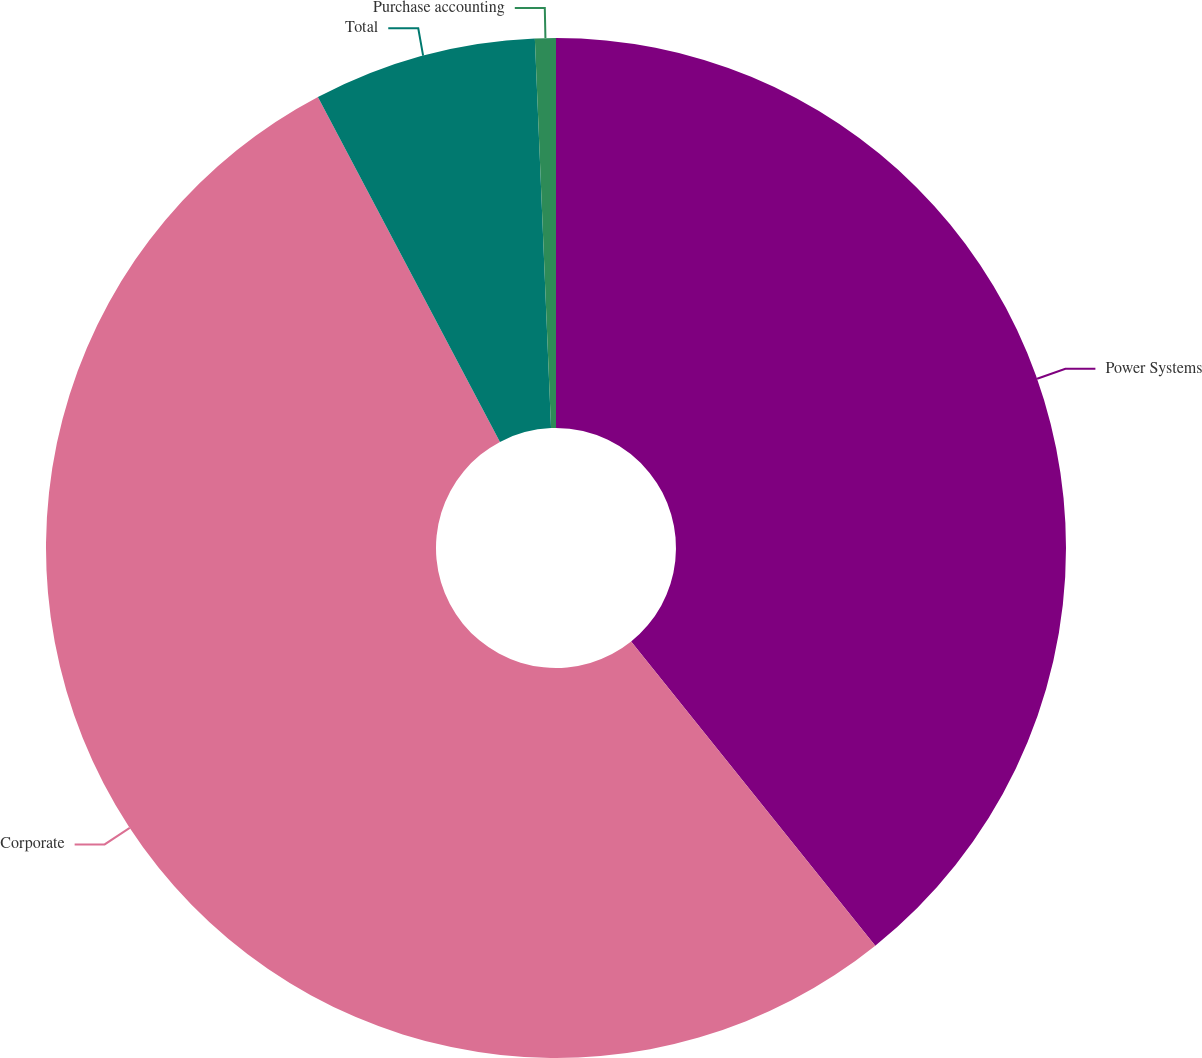<chart> <loc_0><loc_0><loc_500><loc_500><pie_chart><fcel>Power Systems<fcel>Corporate<fcel>Total<fcel>Purchase accounting<nl><fcel>39.23%<fcel>53.03%<fcel>7.07%<fcel>0.66%<nl></chart> 